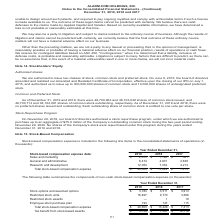According to Alarmcom Holdings's financial document, What was the amount of sales and marketing in 2019? According to the financial document, 2,075 (in thousands). The relevant text states: "xpense data: 2019 2018 2017 Sales and marketing $ 2,075 $ 1,196 $ 561 General and administrative 6,474 4,901 2,638 Research and development 12,054 7,332 4,..." Also, What was the General and administrative in 2018? According to the financial document, 4,901 (in thousands). The relevant text states: "75 $ 1,196 $ 561 General and administrative 6,474 4,901 2,638 Research and development 12,054 7,332 4,214 Total stock-based compensation expense $ 20,603 $..." Also, What was the Research and development in 2017? According to the financial document, 4,214 (in thousands). The relevant text states: "4,901 2,638 Research and development 12,054 7,332 4,214 Total stock-based compensation expense $ 20,603 $ 13,429 $ 7,413..." Also, can you calculate: What was the change in the Sales and marketing between 2018 and 2019? Based on the calculation: 2,075-1,196, the result is 879 (in thousands). This is based on the information: "xpense data: 2019 2018 2017 Sales and marketing $ 2,075 $ 1,196 $ 561 General and administrative 6,474 4,901 2,638 Research and development 12,054 7,332 4, ata: 2019 2018 2017 Sales and marketing $ 2,..." The key data points involved are: 1,196, 2,075. Also, How many years did General and administrative exceed $4,000 thousand? Counting the relevant items in the document: 2019, 2018, I find 2 instances. The key data points involved are: 2018, 2019. Also, can you calculate: What was the percentage change in the Total stock-based compensation expense between 2017 and 2018? To answer this question, I need to perform calculations using the financial data. The calculation is: (13,429-7,413)/7,413, which equals 81.15 (percentage). This is based on the information: "ck-based compensation expense $ 20,603 $ 13,429 $ 7,413 Total stock-based compensation expense $ 20,603 $ 13,429 $ 7,413..." The key data points involved are: 13,429, 7,413. 